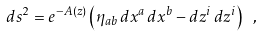<formula> <loc_0><loc_0><loc_500><loc_500>d s ^ { 2 } = e ^ { - A ( z ) } \left ( \eta _ { a b } \, d x ^ { a } \, d x ^ { b } - d z ^ { i } \, d z ^ { i } \right ) \ ,</formula> 